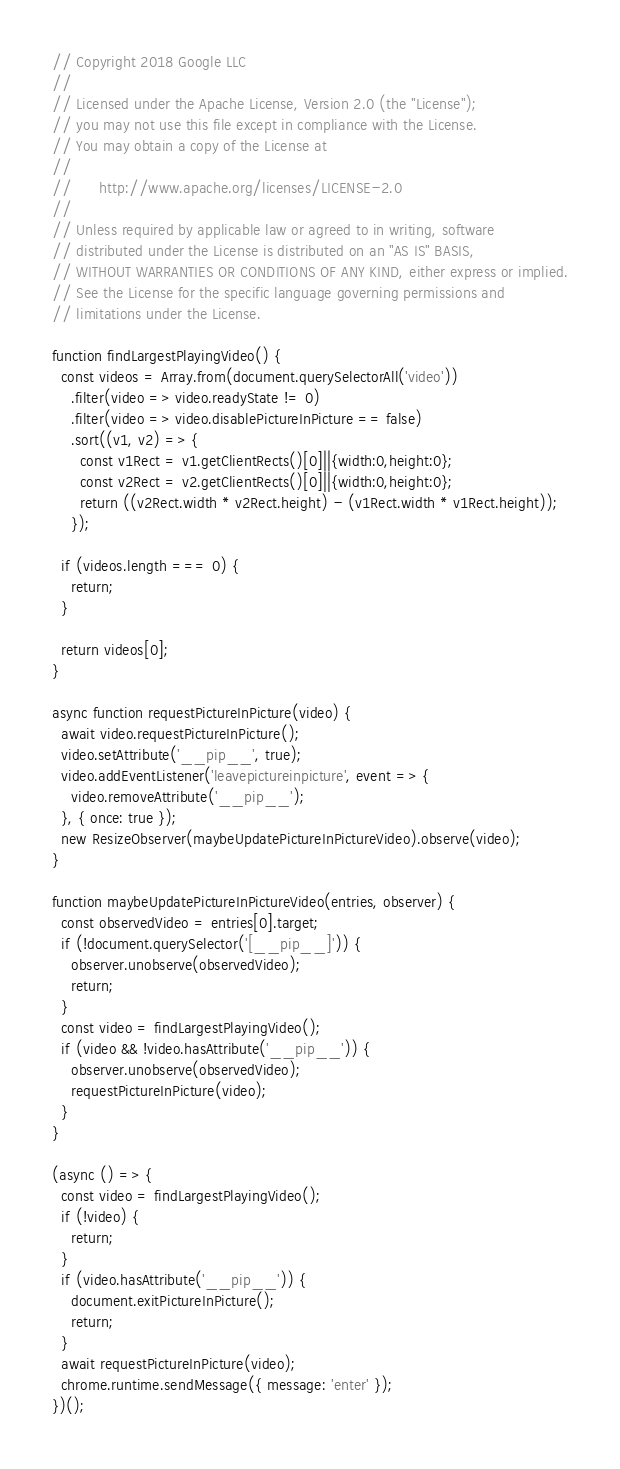<code> <loc_0><loc_0><loc_500><loc_500><_JavaScript_>// Copyright 2018 Google LLC
//
// Licensed under the Apache License, Version 2.0 (the "License");
// you may not use this file except in compliance with the License.
// You may obtain a copy of the License at
//
//      http://www.apache.org/licenses/LICENSE-2.0
//
// Unless required by applicable law or agreed to in writing, software
// distributed under the License is distributed on an "AS IS" BASIS,
// WITHOUT WARRANTIES OR CONDITIONS OF ANY KIND, either express or implied.
// See the License for the specific language governing permissions and
// limitations under the License.

function findLargestPlayingVideo() {
  const videos = Array.from(document.querySelectorAll('video'))
    .filter(video => video.readyState != 0)
    .filter(video => video.disablePictureInPicture == false)
    .sort((v1, v2) => {
      const v1Rect = v1.getClientRects()[0]||{width:0,height:0};
      const v2Rect = v2.getClientRects()[0]||{width:0,height:0};
      return ((v2Rect.width * v2Rect.height) - (v1Rect.width * v1Rect.height));
    });

  if (videos.length === 0) {
    return;
  }

  return videos[0];
}

async function requestPictureInPicture(video) {
  await video.requestPictureInPicture();
  video.setAttribute('__pip__', true);
  video.addEventListener('leavepictureinpicture', event => {
    video.removeAttribute('__pip__');
  }, { once: true });
  new ResizeObserver(maybeUpdatePictureInPictureVideo).observe(video);
}

function maybeUpdatePictureInPictureVideo(entries, observer) {
  const observedVideo = entries[0].target;
  if (!document.querySelector('[__pip__]')) {
    observer.unobserve(observedVideo);
    return;
  }
  const video = findLargestPlayingVideo();
  if (video && !video.hasAttribute('__pip__')) {
    observer.unobserve(observedVideo);
    requestPictureInPicture(video);
  }
}

(async () => {
  const video = findLargestPlayingVideo();
  if (!video) {
    return;
  }
  if (video.hasAttribute('__pip__')) {
    document.exitPictureInPicture();
    return;
  }
  await requestPictureInPicture(video);
  chrome.runtime.sendMessage({ message: 'enter' });
})();
</code> 